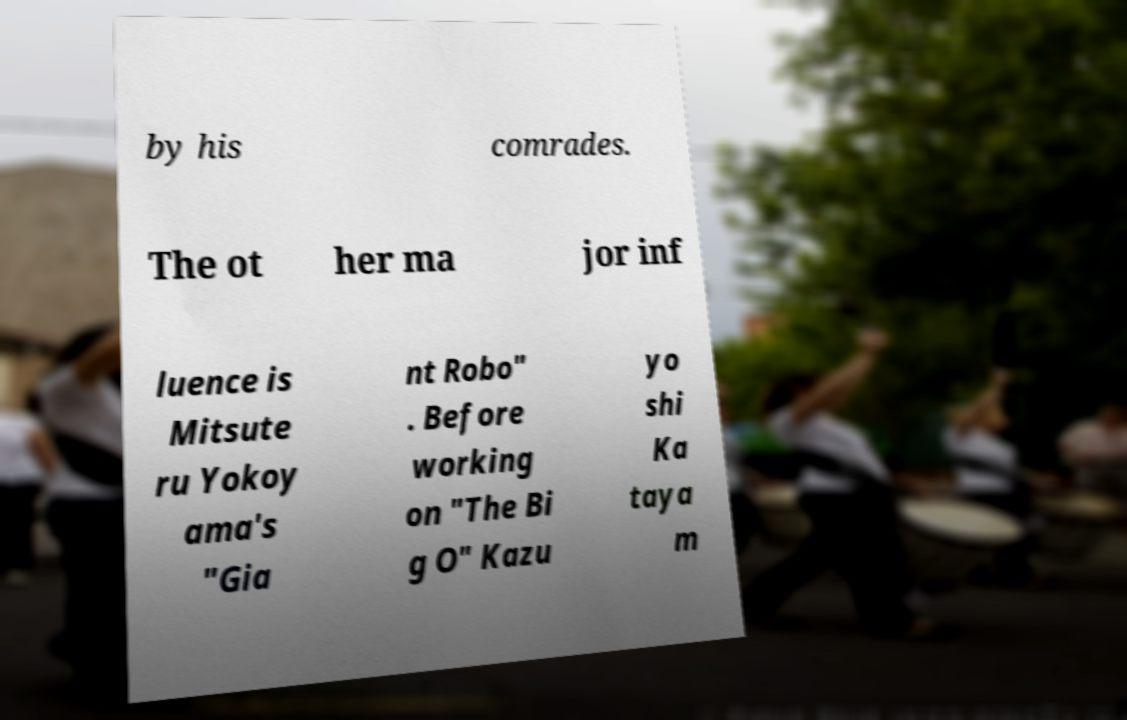For documentation purposes, I need the text within this image transcribed. Could you provide that? by his comrades. The ot her ma jor inf luence is Mitsute ru Yokoy ama's "Gia nt Robo" . Before working on "The Bi g O" Kazu yo shi Ka taya m 